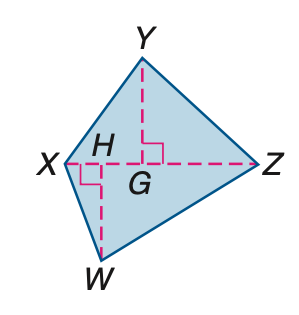Question: Find the area of quadrilateral X Y Z W if X Z = 39, H W = 20, and Y G = 21.
Choices:
A. 390
B. 409.5
C. 799.5
D. 1599
Answer with the letter. Answer: C 